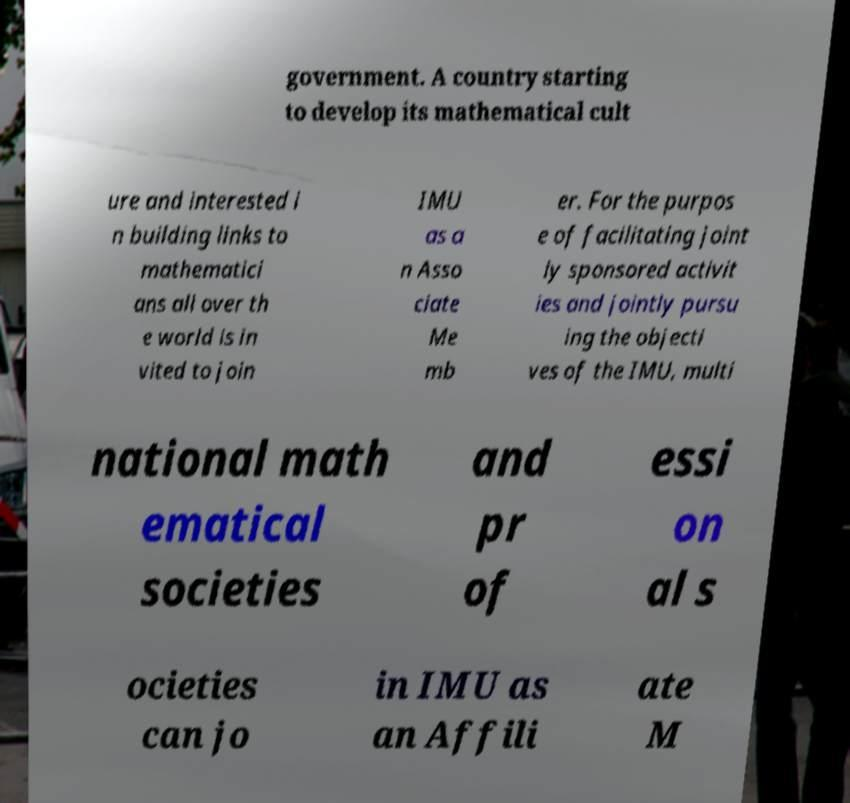For documentation purposes, I need the text within this image transcribed. Could you provide that? government. A country starting to develop its mathematical cult ure and interested i n building links to mathematici ans all over th e world is in vited to join IMU as a n Asso ciate Me mb er. For the purpos e of facilitating joint ly sponsored activit ies and jointly pursu ing the objecti ves of the IMU, multi national math ematical societies and pr of essi on al s ocieties can jo in IMU as an Affili ate M 